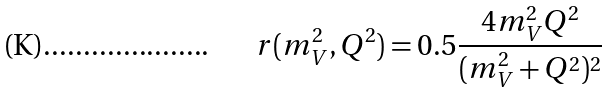<formula> <loc_0><loc_0><loc_500><loc_500>r ( m _ { V } ^ { 2 } , Q ^ { 2 } ) = 0 . 5 \frac { 4 m _ { V } ^ { 2 } Q ^ { 2 } } { ( m _ { V } ^ { 2 } + Q ^ { 2 } ) ^ { 2 } }</formula> 